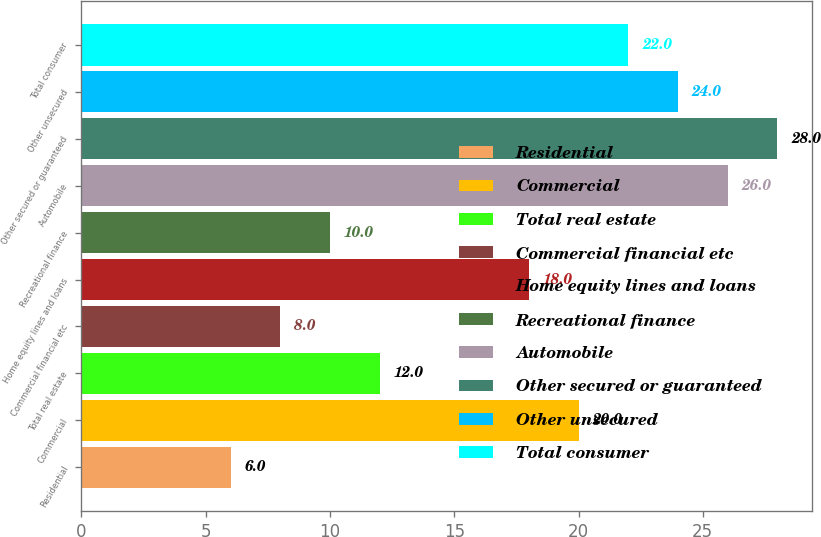Convert chart to OTSL. <chart><loc_0><loc_0><loc_500><loc_500><bar_chart><fcel>Residential<fcel>Commercial<fcel>Total real estate<fcel>Commercial financial etc<fcel>Home equity lines and loans<fcel>Recreational finance<fcel>Automobile<fcel>Other secured or guaranteed<fcel>Other unsecured<fcel>Total consumer<nl><fcel>6<fcel>20<fcel>12<fcel>8<fcel>18<fcel>10<fcel>26<fcel>28<fcel>24<fcel>22<nl></chart> 